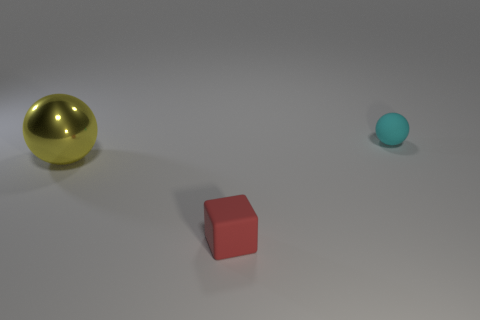There is a object behind the big yellow thing; is its color the same as the tiny matte thing in front of the shiny ball?
Ensure brevity in your answer.  No. What number of other objects are there of the same size as the rubber cube?
Your response must be concise. 1. Is there a object that is in front of the rubber object behind the object to the left of the tiny red rubber block?
Your answer should be very brief. Yes. Is the material of the object behind the big yellow metallic sphere the same as the small red object?
Give a very brief answer. Yes. What is the color of the large metallic object that is the same shape as the cyan rubber thing?
Keep it short and to the point. Yellow. Is there anything else that is the same shape as the red matte object?
Offer a terse response. No. Are there the same number of matte objects that are in front of the big yellow metallic sphere and rubber balls?
Your response must be concise. Yes. There is a large yellow metallic ball; are there any big yellow objects to the right of it?
Give a very brief answer. No. What size is the rubber object that is behind the tiny matte thing left of the rubber object that is behind the metallic sphere?
Offer a terse response. Small. There is a rubber object that is right of the red rubber object; does it have the same shape as the thing that is to the left of the tiny red block?
Give a very brief answer. Yes. 